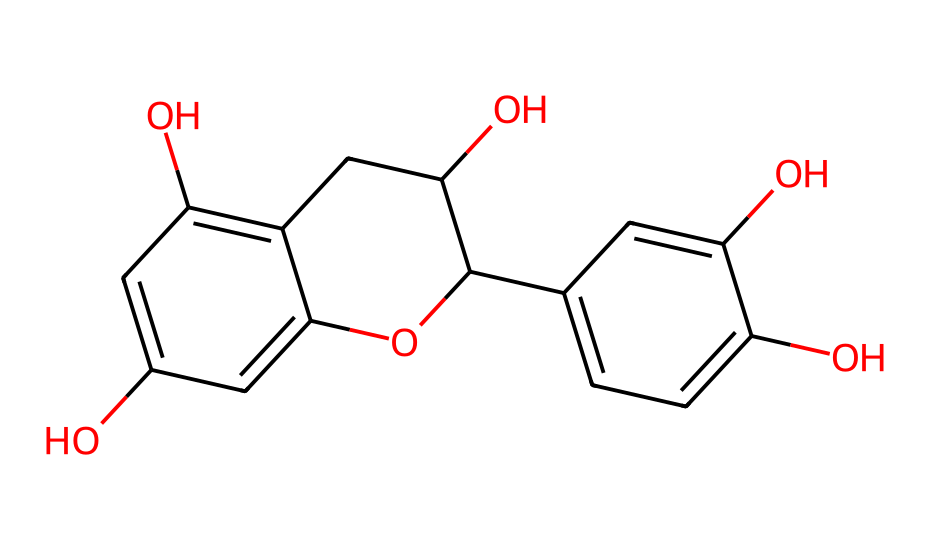What is the total number of hydroxyl (-OH) groups in this chemical? By examining the structure, we can identify the hydroxyl groups typically represented as -OH. Counting the groups in the structure, there are three hydroxyl groups present.
Answer: three What type of ring structure is present in the chemical? Upon examining the structure, we can identify that there are two aromatic rings present, which are primarily characterized by alternating double bonds. These rings contribute to the compound's properties.
Answer: aromatic How many carbon atoms are in the chemical? The structure provides clear visual cues regarding the carbon atoms. By counting each carbon atom represented in the structure, we find a total of 15 carbon atoms.
Answer: fifteen Does this chemical structure contain any methoxy (-OCH3) groups? Looking at the structure, we notice that there are no methoxy groups (-OCH3), as these groups would entail a carbon atom attached to an oxygen atom which in turn is attached to three hydrogens. This isn't present in the chemical.
Answer: no What is the primary biological role of polyphenols like this chemical? Polyphenols are renowned for their antioxidant properties. This structural characteristic allows them to scavenge free radicals, thus playing a crucial role in protecting cellular components from oxidative damage.
Answer: antioxidant What is the oxidation state of the carbon atoms in the ring structure? To determine the oxidation states of the carbon atoms in the rings, we can consider their bonding. Generally, aromatic carbon atoms have an oxidation state of zero, due to their bonding with other carbon atoms and hydrogens.
Answer: zero 